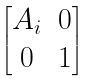Convert formula to latex. <formula><loc_0><loc_0><loc_500><loc_500>\begin{bmatrix} A _ { i } & 0 \\ 0 & 1 \end{bmatrix}</formula> 